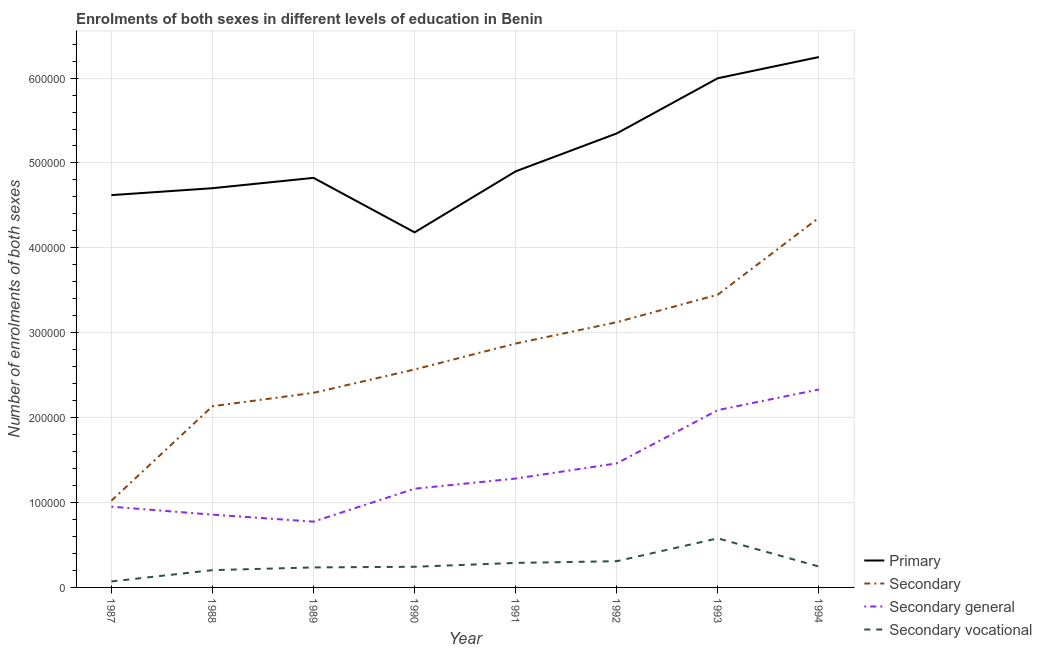How many different coloured lines are there?
Keep it short and to the point. 4. Does the line corresponding to number of enrolments in primary education intersect with the line corresponding to number of enrolments in secondary vocational education?
Your answer should be very brief. No. Is the number of lines equal to the number of legend labels?
Give a very brief answer. Yes. What is the number of enrolments in secondary vocational education in 1987?
Your answer should be very brief. 7050. Across all years, what is the maximum number of enrolments in secondary general education?
Provide a short and direct response. 2.33e+05. Across all years, what is the minimum number of enrolments in primary education?
Provide a succinct answer. 4.18e+05. In which year was the number of enrolments in primary education maximum?
Offer a terse response. 1994. What is the total number of enrolments in primary education in the graph?
Your answer should be compact. 4.08e+06. What is the difference between the number of enrolments in secondary vocational education in 1989 and that in 1990?
Offer a very short reply. -775. What is the difference between the number of enrolments in secondary general education in 1992 and the number of enrolments in primary education in 1991?
Give a very brief answer. -3.44e+05. What is the average number of enrolments in secondary general education per year?
Provide a short and direct response. 1.36e+05. In the year 1994, what is the difference between the number of enrolments in secondary vocational education and number of enrolments in primary education?
Your answer should be very brief. -6.00e+05. What is the ratio of the number of enrolments in secondary vocational education in 1988 to that in 1993?
Offer a very short reply. 0.35. Is the number of enrolments in secondary general education in 1990 less than that in 1991?
Offer a very short reply. Yes. Is the difference between the number of enrolments in secondary education in 1988 and 1992 greater than the difference between the number of enrolments in primary education in 1988 and 1992?
Your answer should be compact. No. What is the difference between the highest and the second highest number of enrolments in primary education?
Give a very brief answer. 2.49e+04. What is the difference between the highest and the lowest number of enrolments in secondary vocational education?
Your response must be concise. 5.08e+04. In how many years, is the number of enrolments in secondary vocational education greater than the average number of enrolments in secondary vocational education taken over all years?
Give a very brief answer. 3. Is it the case that in every year, the sum of the number of enrolments in primary education and number of enrolments in secondary vocational education is greater than the sum of number of enrolments in secondary education and number of enrolments in secondary general education?
Offer a very short reply. No. Does the number of enrolments in secondary education monotonically increase over the years?
Your answer should be very brief. Yes. How many lines are there?
Offer a very short reply. 4. What is the difference between two consecutive major ticks on the Y-axis?
Keep it short and to the point. 1.00e+05. Are the values on the major ticks of Y-axis written in scientific E-notation?
Provide a short and direct response. No. Does the graph contain grids?
Keep it short and to the point. Yes. How many legend labels are there?
Keep it short and to the point. 4. How are the legend labels stacked?
Your answer should be compact. Vertical. What is the title of the graph?
Your answer should be very brief. Enrolments of both sexes in different levels of education in Benin. Does "Efficiency of custom clearance process" appear as one of the legend labels in the graph?
Offer a very short reply. No. What is the label or title of the X-axis?
Provide a succinct answer. Year. What is the label or title of the Y-axis?
Ensure brevity in your answer.  Number of enrolments of both sexes. What is the Number of enrolments of both sexes of Primary in 1987?
Offer a terse response. 4.62e+05. What is the Number of enrolments of both sexes in Secondary in 1987?
Ensure brevity in your answer.  1.02e+05. What is the Number of enrolments of both sexes of Secondary general in 1987?
Offer a terse response. 9.51e+04. What is the Number of enrolments of both sexes of Secondary vocational in 1987?
Provide a short and direct response. 7050. What is the Number of enrolments of both sexes in Primary in 1988?
Your answer should be very brief. 4.70e+05. What is the Number of enrolments of both sexes of Secondary in 1988?
Offer a very short reply. 2.13e+05. What is the Number of enrolments of both sexes of Secondary general in 1988?
Make the answer very short. 8.58e+04. What is the Number of enrolments of both sexes in Secondary vocational in 1988?
Offer a terse response. 2.03e+04. What is the Number of enrolments of both sexes in Primary in 1989?
Provide a short and direct response. 4.82e+05. What is the Number of enrolments of both sexes in Secondary in 1989?
Provide a short and direct response. 2.29e+05. What is the Number of enrolments of both sexes in Secondary general in 1989?
Give a very brief answer. 7.75e+04. What is the Number of enrolments of both sexes of Secondary vocational in 1989?
Give a very brief answer. 2.36e+04. What is the Number of enrolments of both sexes in Primary in 1990?
Ensure brevity in your answer.  4.18e+05. What is the Number of enrolments of both sexes of Secondary in 1990?
Your response must be concise. 2.57e+05. What is the Number of enrolments of both sexes of Secondary general in 1990?
Ensure brevity in your answer.  1.16e+05. What is the Number of enrolments of both sexes in Secondary vocational in 1990?
Give a very brief answer. 2.43e+04. What is the Number of enrolments of both sexes in Primary in 1991?
Make the answer very short. 4.90e+05. What is the Number of enrolments of both sexes of Secondary in 1991?
Provide a short and direct response. 2.87e+05. What is the Number of enrolments of both sexes of Secondary general in 1991?
Your answer should be very brief. 1.28e+05. What is the Number of enrolments of both sexes of Secondary vocational in 1991?
Keep it short and to the point. 2.89e+04. What is the Number of enrolments of both sexes in Primary in 1992?
Your answer should be very brief. 5.35e+05. What is the Number of enrolments of both sexes of Secondary in 1992?
Ensure brevity in your answer.  3.12e+05. What is the Number of enrolments of both sexes of Secondary general in 1992?
Provide a succinct answer. 1.46e+05. What is the Number of enrolments of both sexes of Secondary vocational in 1992?
Offer a terse response. 3.09e+04. What is the Number of enrolments of both sexes of Primary in 1993?
Keep it short and to the point. 6.00e+05. What is the Number of enrolments of both sexes in Secondary in 1993?
Your answer should be compact. 3.45e+05. What is the Number of enrolments of both sexes of Secondary general in 1993?
Offer a very short reply. 2.09e+05. What is the Number of enrolments of both sexes in Secondary vocational in 1993?
Your answer should be very brief. 5.78e+04. What is the Number of enrolments of both sexes in Primary in 1994?
Offer a terse response. 6.25e+05. What is the Number of enrolments of both sexes of Secondary in 1994?
Make the answer very short. 4.35e+05. What is the Number of enrolments of both sexes of Secondary general in 1994?
Give a very brief answer. 2.33e+05. What is the Number of enrolments of both sexes in Secondary vocational in 1994?
Keep it short and to the point. 2.46e+04. Across all years, what is the maximum Number of enrolments of both sexes in Primary?
Ensure brevity in your answer.  6.25e+05. Across all years, what is the maximum Number of enrolments of both sexes of Secondary?
Offer a very short reply. 4.35e+05. Across all years, what is the maximum Number of enrolments of both sexes in Secondary general?
Your answer should be very brief. 2.33e+05. Across all years, what is the maximum Number of enrolments of both sexes in Secondary vocational?
Give a very brief answer. 5.78e+04. Across all years, what is the minimum Number of enrolments of both sexes of Primary?
Keep it short and to the point. 4.18e+05. Across all years, what is the minimum Number of enrolments of both sexes of Secondary?
Your response must be concise. 1.02e+05. Across all years, what is the minimum Number of enrolments of both sexes in Secondary general?
Your response must be concise. 7.75e+04. Across all years, what is the minimum Number of enrolments of both sexes of Secondary vocational?
Your answer should be compact. 7050. What is the total Number of enrolments of both sexes of Primary in the graph?
Ensure brevity in your answer.  4.08e+06. What is the total Number of enrolments of both sexes of Secondary in the graph?
Keep it short and to the point. 2.18e+06. What is the total Number of enrolments of both sexes of Secondary general in the graph?
Offer a very short reply. 1.09e+06. What is the total Number of enrolments of both sexes of Secondary vocational in the graph?
Give a very brief answer. 2.18e+05. What is the difference between the Number of enrolments of both sexes in Primary in 1987 and that in 1988?
Your answer should be compact. -8157. What is the difference between the Number of enrolments of both sexes of Secondary in 1987 and that in 1988?
Your response must be concise. -1.11e+05. What is the difference between the Number of enrolments of both sexes in Secondary general in 1987 and that in 1988?
Ensure brevity in your answer.  9368. What is the difference between the Number of enrolments of both sexes in Secondary vocational in 1987 and that in 1988?
Give a very brief answer. -1.33e+04. What is the difference between the Number of enrolments of both sexes of Primary in 1987 and that in 1989?
Make the answer very short. -2.03e+04. What is the difference between the Number of enrolments of both sexes of Secondary in 1987 and that in 1989?
Offer a very short reply. -1.27e+05. What is the difference between the Number of enrolments of both sexes of Secondary general in 1987 and that in 1989?
Make the answer very short. 1.76e+04. What is the difference between the Number of enrolments of both sexes in Secondary vocational in 1987 and that in 1989?
Offer a very short reply. -1.65e+04. What is the difference between the Number of enrolments of both sexes of Primary in 1987 and that in 1990?
Your response must be concise. 4.38e+04. What is the difference between the Number of enrolments of both sexes in Secondary in 1987 and that in 1990?
Provide a short and direct response. -1.55e+05. What is the difference between the Number of enrolments of both sexes of Secondary general in 1987 and that in 1990?
Your answer should be compact. -2.12e+04. What is the difference between the Number of enrolments of both sexes in Secondary vocational in 1987 and that in 1990?
Make the answer very short. -1.73e+04. What is the difference between the Number of enrolments of both sexes in Primary in 1987 and that in 1991?
Your answer should be compact. -2.80e+04. What is the difference between the Number of enrolments of both sexes in Secondary in 1987 and that in 1991?
Make the answer very short. -1.85e+05. What is the difference between the Number of enrolments of both sexes in Secondary general in 1987 and that in 1991?
Give a very brief answer. -3.31e+04. What is the difference between the Number of enrolments of both sexes in Secondary vocational in 1987 and that in 1991?
Your response must be concise. -2.18e+04. What is the difference between the Number of enrolments of both sexes in Primary in 1987 and that in 1992?
Offer a terse response. -7.27e+04. What is the difference between the Number of enrolments of both sexes in Secondary in 1987 and that in 1992?
Keep it short and to the point. -2.10e+05. What is the difference between the Number of enrolments of both sexes of Secondary general in 1987 and that in 1992?
Offer a terse response. -5.10e+04. What is the difference between the Number of enrolments of both sexes of Secondary vocational in 1987 and that in 1992?
Provide a succinct answer. -2.39e+04. What is the difference between the Number of enrolments of both sexes in Primary in 1987 and that in 1993?
Give a very brief answer. -1.38e+05. What is the difference between the Number of enrolments of both sexes of Secondary in 1987 and that in 1993?
Provide a succinct answer. -2.43e+05. What is the difference between the Number of enrolments of both sexes of Secondary general in 1987 and that in 1993?
Make the answer very short. -1.14e+05. What is the difference between the Number of enrolments of both sexes in Secondary vocational in 1987 and that in 1993?
Your response must be concise. -5.08e+04. What is the difference between the Number of enrolments of both sexes of Primary in 1987 and that in 1994?
Make the answer very short. -1.63e+05. What is the difference between the Number of enrolments of both sexes in Secondary in 1987 and that in 1994?
Your answer should be compact. -3.33e+05. What is the difference between the Number of enrolments of both sexes in Secondary general in 1987 and that in 1994?
Your response must be concise. -1.38e+05. What is the difference between the Number of enrolments of both sexes of Secondary vocational in 1987 and that in 1994?
Your answer should be compact. -1.76e+04. What is the difference between the Number of enrolments of both sexes of Primary in 1988 and that in 1989?
Your response must be concise. -1.22e+04. What is the difference between the Number of enrolments of both sexes of Secondary in 1988 and that in 1989?
Your response must be concise. -1.58e+04. What is the difference between the Number of enrolments of both sexes in Secondary general in 1988 and that in 1989?
Ensure brevity in your answer.  8253. What is the difference between the Number of enrolments of both sexes of Secondary vocational in 1988 and that in 1989?
Offer a terse response. -3224. What is the difference between the Number of enrolments of both sexes in Primary in 1988 and that in 1990?
Your answer should be very brief. 5.20e+04. What is the difference between the Number of enrolments of both sexes in Secondary in 1988 and that in 1990?
Ensure brevity in your answer.  -4.33e+04. What is the difference between the Number of enrolments of both sexes of Secondary general in 1988 and that in 1990?
Your answer should be compact. -3.05e+04. What is the difference between the Number of enrolments of both sexes of Secondary vocational in 1988 and that in 1990?
Provide a succinct answer. -3999. What is the difference between the Number of enrolments of both sexes of Primary in 1988 and that in 1991?
Give a very brief answer. -1.99e+04. What is the difference between the Number of enrolments of both sexes in Secondary in 1988 and that in 1991?
Ensure brevity in your answer.  -7.38e+04. What is the difference between the Number of enrolments of both sexes of Secondary general in 1988 and that in 1991?
Make the answer very short. -4.25e+04. What is the difference between the Number of enrolments of both sexes of Secondary vocational in 1988 and that in 1991?
Ensure brevity in your answer.  -8524. What is the difference between the Number of enrolments of both sexes of Primary in 1988 and that in 1992?
Offer a terse response. -6.45e+04. What is the difference between the Number of enrolments of both sexes in Secondary in 1988 and that in 1992?
Provide a succinct answer. -9.90e+04. What is the difference between the Number of enrolments of both sexes of Secondary general in 1988 and that in 1992?
Provide a succinct answer. -6.04e+04. What is the difference between the Number of enrolments of both sexes of Secondary vocational in 1988 and that in 1992?
Provide a succinct answer. -1.06e+04. What is the difference between the Number of enrolments of both sexes of Primary in 1988 and that in 1993?
Make the answer very short. -1.30e+05. What is the difference between the Number of enrolments of both sexes of Secondary in 1988 and that in 1993?
Your answer should be very brief. -1.31e+05. What is the difference between the Number of enrolments of both sexes of Secondary general in 1988 and that in 1993?
Keep it short and to the point. -1.23e+05. What is the difference between the Number of enrolments of both sexes of Secondary vocational in 1988 and that in 1993?
Keep it short and to the point. -3.75e+04. What is the difference between the Number of enrolments of both sexes in Primary in 1988 and that in 1994?
Make the answer very short. -1.55e+05. What is the difference between the Number of enrolments of both sexes of Secondary in 1988 and that in 1994?
Provide a short and direct response. -2.22e+05. What is the difference between the Number of enrolments of both sexes in Secondary general in 1988 and that in 1994?
Your answer should be compact. -1.47e+05. What is the difference between the Number of enrolments of both sexes of Secondary vocational in 1988 and that in 1994?
Your answer should be compact. -4283. What is the difference between the Number of enrolments of both sexes of Primary in 1989 and that in 1990?
Your response must be concise. 6.42e+04. What is the difference between the Number of enrolments of both sexes in Secondary in 1989 and that in 1990?
Make the answer very short. -2.75e+04. What is the difference between the Number of enrolments of both sexes of Secondary general in 1989 and that in 1990?
Give a very brief answer. -3.88e+04. What is the difference between the Number of enrolments of both sexes in Secondary vocational in 1989 and that in 1990?
Your answer should be very brief. -775. What is the difference between the Number of enrolments of both sexes in Primary in 1989 and that in 1991?
Make the answer very short. -7678. What is the difference between the Number of enrolments of both sexes in Secondary in 1989 and that in 1991?
Provide a short and direct response. -5.81e+04. What is the difference between the Number of enrolments of both sexes in Secondary general in 1989 and that in 1991?
Ensure brevity in your answer.  -5.08e+04. What is the difference between the Number of enrolments of both sexes of Secondary vocational in 1989 and that in 1991?
Provide a succinct answer. -5300. What is the difference between the Number of enrolments of both sexes in Primary in 1989 and that in 1992?
Make the answer very short. -5.24e+04. What is the difference between the Number of enrolments of both sexes of Secondary in 1989 and that in 1992?
Provide a succinct answer. -8.32e+04. What is the difference between the Number of enrolments of both sexes of Secondary general in 1989 and that in 1992?
Offer a very short reply. -6.86e+04. What is the difference between the Number of enrolments of both sexes in Secondary vocational in 1989 and that in 1992?
Offer a very short reply. -7337. What is the difference between the Number of enrolments of both sexes in Primary in 1989 and that in 1993?
Ensure brevity in your answer.  -1.17e+05. What is the difference between the Number of enrolments of both sexes in Secondary in 1989 and that in 1993?
Make the answer very short. -1.16e+05. What is the difference between the Number of enrolments of both sexes of Secondary general in 1989 and that in 1993?
Your answer should be very brief. -1.31e+05. What is the difference between the Number of enrolments of both sexes of Secondary vocational in 1989 and that in 1993?
Provide a succinct answer. -3.43e+04. What is the difference between the Number of enrolments of both sexes of Primary in 1989 and that in 1994?
Ensure brevity in your answer.  -1.42e+05. What is the difference between the Number of enrolments of both sexes of Secondary in 1989 and that in 1994?
Provide a short and direct response. -2.06e+05. What is the difference between the Number of enrolments of both sexes in Secondary general in 1989 and that in 1994?
Make the answer very short. -1.56e+05. What is the difference between the Number of enrolments of both sexes of Secondary vocational in 1989 and that in 1994?
Your response must be concise. -1059. What is the difference between the Number of enrolments of both sexes of Primary in 1990 and that in 1991?
Offer a terse response. -7.19e+04. What is the difference between the Number of enrolments of both sexes of Secondary in 1990 and that in 1991?
Provide a short and direct response. -3.05e+04. What is the difference between the Number of enrolments of both sexes in Secondary general in 1990 and that in 1991?
Offer a terse response. -1.20e+04. What is the difference between the Number of enrolments of both sexes in Secondary vocational in 1990 and that in 1991?
Your answer should be compact. -4525. What is the difference between the Number of enrolments of both sexes in Primary in 1990 and that in 1992?
Give a very brief answer. -1.17e+05. What is the difference between the Number of enrolments of both sexes of Secondary in 1990 and that in 1992?
Your answer should be very brief. -5.57e+04. What is the difference between the Number of enrolments of both sexes in Secondary general in 1990 and that in 1992?
Make the answer very short. -2.98e+04. What is the difference between the Number of enrolments of both sexes in Secondary vocational in 1990 and that in 1992?
Provide a succinct answer. -6562. What is the difference between the Number of enrolments of both sexes in Primary in 1990 and that in 1993?
Ensure brevity in your answer.  -1.82e+05. What is the difference between the Number of enrolments of both sexes of Secondary in 1990 and that in 1993?
Offer a very short reply. -8.81e+04. What is the difference between the Number of enrolments of both sexes of Secondary general in 1990 and that in 1993?
Offer a very short reply. -9.26e+04. What is the difference between the Number of enrolments of both sexes in Secondary vocational in 1990 and that in 1993?
Your answer should be very brief. -3.35e+04. What is the difference between the Number of enrolments of both sexes in Primary in 1990 and that in 1994?
Keep it short and to the point. -2.07e+05. What is the difference between the Number of enrolments of both sexes in Secondary in 1990 and that in 1994?
Ensure brevity in your answer.  -1.79e+05. What is the difference between the Number of enrolments of both sexes in Secondary general in 1990 and that in 1994?
Your answer should be compact. -1.17e+05. What is the difference between the Number of enrolments of both sexes in Secondary vocational in 1990 and that in 1994?
Provide a short and direct response. -284. What is the difference between the Number of enrolments of both sexes in Primary in 1991 and that in 1992?
Provide a short and direct response. -4.47e+04. What is the difference between the Number of enrolments of both sexes of Secondary in 1991 and that in 1992?
Offer a terse response. -2.51e+04. What is the difference between the Number of enrolments of both sexes in Secondary general in 1991 and that in 1992?
Your answer should be compact. -1.79e+04. What is the difference between the Number of enrolments of both sexes of Secondary vocational in 1991 and that in 1992?
Your answer should be very brief. -2037. What is the difference between the Number of enrolments of both sexes in Primary in 1991 and that in 1993?
Keep it short and to the point. -1.10e+05. What is the difference between the Number of enrolments of both sexes of Secondary in 1991 and that in 1993?
Provide a short and direct response. -5.76e+04. What is the difference between the Number of enrolments of both sexes of Secondary general in 1991 and that in 1993?
Offer a very short reply. -8.06e+04. What is the difference between the Number of enrolments of both sexes in Secondary vocational in 1991 and that in 1993?
Provide a short and direct response. -2.90e+04. What is the difference between the Number of enrolments of both sexes of Primary in 1991 and that in 1994?
Offer a very short reply. -1.35e+05. What is the difference between the Number of enrolments of both sexes of Secondary in 1991 and that in 1994?
Your answer should be compact. -1.48e+05. What is the difference between the Number of enrolments of both sexes of Secondary general in 1991 and that in 1994?
Keep it short and to the point. -1.05e+05. What is the difference between the Number of enrolments of both sexes of Secondary vocational in 1991 and that in 1994?
Keep it short and to the point. 4241. What is the difference between the Number of enrolments of both sexes in Primary in 1992 and that in 1993?
Keep it short and to the point. -6.50e+04. What is the difference between the Number of enrolments of both sexes of Secondary in 1992 and that in 1993?
Provide a succinct answer. -3.25e+04. What is the difference between the Number of enrolments of both sexes in Secondary general in 1992 and that in 1993?
Ensure brevity in your answer.  -6.28e+04. What is the difference between the Number of enrolments of both sexes of Secondary vocational in 1992 and that in 1993?
Ensure brevity in your answer.  -2.69e+04. What is the difference between the Number of enrolments of both sexes in Primary in 1992 and that in 1994?
Your response must be concise. -9.00e+04. What is the difference between the Number of enrolments of both sexes in Secondary in 1992 and that in 1994?
Provide a succinct answer. -1.23e+05. What is the difference between the Number of enrolments of both sexes in Secondary general in 1992 and that in 1994?
Your response must be concise. -8.70e+04. What is the difference between the Number of enrolments of both sexes of Secondary vocational in 1992 and that in 1994?
Provide a succinct answer. 6278. What is the difference between the Number of enrolments of both sexes in Primary in 1993 and that in 1994?
Ensure brevity in your answer.  -2.49e+04. What is the difference between the Number of enrolments of both sexes of Secondary in 1993 and that in 1994?
Make the answer very short. -9.06e+04. What is the difference between the Number of enrolments of both sexes of Secondary general in 1993 and that in 1994?
Offer a terse response. -2.43e+04. What is the difference between the Number of enrolments of both sexes in Secondary vocational in 1993 and that in 1994?
Ensure brevity in your answer.  3.32e+04. What is the difference between the Number of enrolments of both sexes in Primary in 1987 and the Number of enrolments of both sexes in Secondary in 1988?
Provide a short and direct response. 2.49e+05. What is the difference between the Number of enrolments of both sexes of Primary in 1987 and the Number of enrolments of both sexes of Secondary general in 1988?
Offer a terse response. 3.76e+05. What is the difference between the Number of enrolments of both sexes of Primary in 1987 and the Number of enrolments of both sexes of Secondary vocational in 1988?
Offer a terse response. 4.42e+05. What is the difference between the Number of enrolments of both sexes of Secondary in 1987 and the Number of enrolments of both sexes of Secondary general in 1988?
Offer a terse response. 1.64e+04. What is the difference between the Number of enrolments of both sexes in Secondary in 1987 and the Number of enrolments of both sexes in Secondary vocational in 1988?
Provide a succinct answer. 8.18e+04. What is the difference between the Number of enrolments of both sexes in Secondary general in 1987 and the Number of enrolments of both sexes in Secondary vocational in 1988?
Ensure brevity in your answer.  7.48e+04. What is the difference between the Number of enrolments of both sexes in Primary in 1987 and the Number of enrolments of both sexes in Secondary in 1989?
Give a very brief answer. 2.33e+05. What is the difference between the Number of enrolments of both sexes in Primary in 1987 and the Number of enrolments of both sexes in Secondary general in 1989?
Provide a succinct answer. 3.85e+05. What is the difference between the Number of enrolments of both sexes of Primary in 1987 and the Number of enrolments of both sexes of Secondary vocational in 1989?
Give a very brief answer. 4.39e+05. What is the difference between the Number of enrolments of both sexes of Secondary in 1987 and the Number of enrolments of both sexes of Secondary general in 1989?
Offer a terse response. 2.47e+04. What is the difference between the Number of enrolments of both sexes in Secondary in 1987 and the Number of enrolments of both sexes in Secondary vocational in 1989?
Keep it short and to the point. 7.86e+04. What is the difference between the Number of enrolments of both sexes of Secondary general in 1987 and the Number of enrolments of both sexes of Secondary vocational in 1989?
Provide a succinct answer. 7.16e+04. What is the difference between the Number of enrolments of both sexes of Primary in 1987 and the Number of enrolments of both sexes of Secondary in 1990?
Offer a terse response. 2.05e+05. What is the difference between the Number of enrolments of both sexes of Primary in 1987 and the Number of enrolments of both sexes of Secondary general in 1990?
Make the answer very short. 3.46e+05. What is the difference between the Number of enrolments of both sexes of Primary in 1987 and the Number of enrolments of both sexes of Secondary vocational in 1990?
Give a very brief answer. 4.38e+05. What is the difference between the Number of enrolments of both sexes of Secondary in 1987 and the Number of enrolments of both sexes of Secondary general in 1990?
Offer a terse response. -1.41e+04. What is the difference between the Number of enrolments of both sexes of Secondary in 1987 and the Number of enrolments of both sexes of Secondary vocational in 1990?
Ensure brevity in your answer.  7.78e+04. What is the difference between the Number of enrolments of both sexes in Secondary general in 1987 and the Number of enrolments of both sexes in Secondary vocational in 1990?
Ensure brevity in your answer.  7.08e+04. What is the difference between the Number of enrolments of both sexes in Primary in 1987 and the Number of enrolments of both sexes in Secondary in 1991?
Offer a terse response. 1.75e+05. What is the difference between the Number of enrolments of both sexes of Primary in 1987 and the Number of enrolments of both sexes of Secondary general in 1991?
Give a very brief answer. 3.34e+05. What is the difference between the Number of enrolments of both sexes of Primary in 1987 and the Number of enrolments of both sexes of Secondary vocational in 1991?
Keep it short and to the point. 4.33e+05. What is the difference between the Number of enrolments of both sexes in Secondary in 1987 and the Number of enrolments of both sexes in Secondary general in 1991?
Give a very brief answer. -2.61e+04. What is the difference between the Number of enrolments of both sexes of Secondary in 1987 and the Number of enrolments of both sexes of Secondary vocational in 1991?
Your answer should be very brief. 7.33e+04. What is the difference between the Number of enrolments of both sexes in Secondary general in 1987 and the Number of enrolments of both sexes in Secondary vocational in 1991?
Provide a short and direct response. 6.63e+04. What is the difference between the Number of enrolments of both sexes of Primary in 1987 and the Number of enrolments of both sexes of Secondary in 1992?
Your answer should be very brief. 1.50e+05. What is the difference between the Number of enrolments of both sexes in Primary in 1987 and the Number of enrolments of both sexes in Secondary general in 1992?
Provide a succinct answer. 3.16e+05. What is the difference between the Number of enrolments of both sexes in Primary in 1987 and the Number of enrolments of both sexes in Secondary vocational in 1992?
Your response must be concise. 4.31e+05. What is the difference between the Number of enrolments of both sexes of Secondary in 1987 and the Number of enrolments of both sexes of Secondary general in 1992?
Offer a very short reply. -4.40e+04. What is the difference between the Number of enrolments of both sexes of Secondary in 1987 and the Number of enrolments of both sexes of Secondary vocational in 1992?
Your response must be concise. 7.13e+04. What is the difference between the Number of enrolments of both sexes in Secondary general in 1987 and the Number of enrolments of both sexes in Secondary vocational in 1992?
Your answer should be very brief. 6.42e+04. What is the difference between the Number of enrolments of both sexes of Primary in 1987 and the Number of enrolments of both sexes of Secondary in 1993?
Provide a short and direct response. 1.17e+05. What is the difference between the Number of enrolments of both sexes in Primary in 1987 and the Number of enrolments of both sexes in Secondary general in 1993?
Offer a very short reply. 2.53e+05. What is the difference between the Number of enrolments of both sexes in Primary in 1987 and the Number of enrolments of both sexes in Secondary vocational in 1993?
Offer a very short reply. 4.04e+05. What is the difference between the Number of enrolments of both sexes of Secondary in 1987 and the Number of enrolments of both sexes of Secondary general in 1993?
Your answer should be very brief. -1.07e+05. What is the difference between the Number of enrolments of both sexes in Secondary in 1987 and the Number of enrolments of both sexes in Secondary vocational in 1993?
Your response must be concise. 4.43e+04. What is the difference between the Number of enrolments of both sexes in Secondary general in 1987 and the Number of enrolments of both sexes in Secondary vocational in 1993?
Provide a succinct answer. 3.73e+04. What is the difference between the Number of enrolments of both sexes of Primary in 1987 and the Number of enrolments of both sexes of Secondary in 1994?
Offer a terse response. 2.67e+04. What is the difference between the Number of enrolments of both sexes in Primary in 1987 and the Number of enrolments of both sexes in Secondary general in 1994?
Keep it short and to the point. 2.29e+05. What is the difference between the Number of enrolments of both sexes in Primary in 1987 and the Number of enrolments of both sexes in Secondary vocational in 1994?
Offer a terse response. 4.37e+05. What is the difference between the Number of enrolments of both sexes of Secondary in 1987 and the Number of enrolments of both sexes of Secondary general in 1994?
Provide a short and direct response. -1.31e+05. What is the difference between the Number of enrolments of both sexes in Secondary in 1987 and the Number of enrolments of both sexes in Secondary vocational in 1994?
Provide a short and direct response. 7.75e+04. What is the difference between the Number of enrolments of both sexes in Secondary general in 1987 and the Number of enrolments of both sexes in Secondary vocational in 1994?
Make the answer very short. 7.05e+04. What is the difference between the Number of enrolments of both sexes in Primary in 1988 and the Number of enrolments of both sexes in Secondary in 1989?
Provide a succinct answer. 2.41e+05. What is the difference between the Number of enrolments of both sexes of Primary in 1988 and the Number of enrolments of both sexes of Secondary general in 1989?
Ensure brevity in your answer.  3.93e+05. What is the difference between the Number of enrolments of both sexes of Primary in 1988 and the Number of enrolments of both sexes of Secondary vocational in 1989?
Offer a very short reply. 4.47e+05. What is the difference between the Number of enrolments of both sexes in Secondary in 1988 and the Number of enrolments of both sexes in Secondary general in 1989?
Make the answer very short. 1.36e+05. What is the difference between the Number of enrolments of both sexes in Secondary in 1988 and the Number of enrolments of both sexes in Secondary vocational in 1989?
Offer a very short reply. 1.90e+05. What is the difference between the Number of enrolments of both sexes of Secondary general in 1988 and the Number of enrolments of both sexes of Secondary vocational in 1989?
Ensure brevity in your answer.  6.22e+04. What is the difference between the Number of enrolments of both sexes of Primary in 1988 and the Number of enrolments of both sexes of Secondary in 1990?
Offer a very short reply. 2.14e+05. What is the difference between the Number of enrolments of both sexes in Primary in 1988 and the Number of enrolments of both sexes in Secondary general in 1990?
Give a very brief answer. 3.54e+05. What is the difference between the Number of enrolments of both sexes of Primary in 1988 and the Number of enrolments of both sexes of Secondary vocational in 1990?
Ensure brevity in your answer.  4.46e+05. What is the difference between the Number of enrolments of both sexes in Secondary in 1988 and the Number of enrolments of both sexes in Secondary general in 1990?
Make the answer very short. 9.72e+04. What is the difference between the Number of enrolments of both sexes in Secondary in 1988 and the Number of enrolments of both sexes in Secondary vocational in 1990?
Your answer should be very brief. 1.89e+05. What is the difference between the Number of enrolments of both sexes of Secondary general in 1988 and the Number of enrolments of both sexes of Secondary vocational in 1990?
Your response must be concise. 6.14e+04. What is the difference between the Number of enrolments of both sexes of Primary in 1988 and the Number of enrolments of both sexes of Secondary in 1991?
Provide a succinct answer. 1.83e+05. What is the difference between the Number of enrolments of both sexes in Primary in 1988 and the Number of enrolments of both sexes in Secondary general in 1991?
Provide a short and direct response. 3.42e+05. What is the difference between the Number of enrolments of both sexes in Primary in 1988 and the Number of enrolments of both sexes in Secondary vocational in 1991?
Your answer should be very brief. 4.41e+05. What is the difference between the Number of enrolments of both sexes in Secondary in 1988 and the Number of enrolments of both sexes in Secondary general in 1991?
Offer a terse response. 8.52e+04. What is the difference between the Number of enrolments of both sexes of Secondary in 1988 and the Number of enrolments of both sexes of Secondary vocational in 1991?
Make the answer very short. 1.85e+05. What is the difference between the Number of enrolments of both sexes in Secondary general in 1988 and the Number of enrolments of both sexes in Secondary vocational in 1991?
Give a very brief answer. 5.69e+04. What is the difference between the Number of enrolments of both sexes in Primary in 1988 and the Number of enrolments of both sexes in Secondary in 1992?
Offer a very short reply. 1.58e+05. What is the difference between the Number of enrolments of both sexes of Primary in 1988 and the Number of enrolments of both sexes of Secondary general in 1992?
Your answer should be compact. 3.24e+05. What is the difference between the Number of enrolments of both sexes in Primary in 1988 and the Number of enrolments of both sexes in Secondary vocational in 1992?
Offer a terse response. 4.39e+05. What is the difference between the Number of enrolments of both sexes in Secondary in 1988 and the Number of enrolments of both sexes in Secondary general in 1992?
Make the answer very short. 6.73e+04. What is the difference between the Number of enrolments of both sexes of Secondary in 1988 and the Number of enrolments of both sexes of Secondary vocational in 1992?
Offer a very short reply. 1.83e+05. What is the difference between the Number of enrolments of both sexes of Secondary general in 1988 and the Number of enrolments of both sexes of Secondary vocational in 1992?
Make the answer very short. 5.48e+04. What is the difference between the Number of enrolments of both sexes in Primary in 1988 and the Number of enrolments of both sexes in Secondary in 1993?
Provide a short and direct response. 1.25e+05. What is the difference between the Number of enrolments of both sexes of Primary in 1988 and the Number of enrolments of both sexes of Secondary general in 1993?
Offer a terse response. 2.61e+05. What is the difference between the Number of enrolments of both sexes of Primary in 1988 and the Number of enrolments of both sexes of Secondary vocational in 1993?
Offer a terse response. 4.12e+05. What is the difference between the Number of enrolments of both sexes of Secondary in 1988 and the Number of enrolments of both sexes of Secondary general in 1993?
Make the answer very short. 4589. What is the difference between the Number of enrolments of both sexes of Secondary in 1988 and the Number of enrolments of both sexes of Secondary vocational in 1993?
Make the answer very short. 1.56e+05. What is the difference between the Number of enrolments of both sexes in Secondary general in 1988 and the Number of enrolments of both sexes in Secondary vocational in 1993?
Keep it short and to the point. 2.79e+04. What is the difference between the Number of enrolments of both sexes in Primary in 1988 and the Number of enrolments of both sexes in Secondary in 1994?
Your response must be concise. 3.48e+04. What is the difference between the Number of enrolments of both sexes in Primary in 1988 and the Number of enrolments of both sexes in Secondary general in 1994?
Make the answer very short. 2.37e+05. What is the difference between the Number of enrolments of both sexes of Primary in 1988 and the Number of enrolments of both sexes of Secondary vocational in 1994?
Your answer should be compact. 4.46e+05. What is the difference between the Number of enrolments of both sexes of Secondary in 1988 and the Number of enrolments of both sexes of Secondary general in 1994?
Your answer should be very brief. -1.97e+04. What is the difference between the Number of enrolments of both sexes of Secondary in 1988 and the Number of enrolments of both sexes of Secondary vocational in 1994?
Keep it short and to the point. 1.89e+05. What is the difference between the Number of enrolments of both sexes in Secondary general in 1988 and the Number of enrolments of both sexes in Secondary vocational in 1994?
Make the answer very short. 6.11e+04. What is the difference between the Number of enrolments of both sexes of Primary in 1989 and the Number of enrolments of both sexes of Secondary in 1990?
Offer a very short reply. 2.26e+05. What is the difference between the Number of enrolments of both sexes in Primary in 1989 and the Number of enrolments of both sexes in Secondary general in 1990?
Make the answer very short. 3.66e+05. What is the difference between the Number of enrolments of both sexes in Primary in 1989 and the Number of enrolments of both sexes in Secondary vocational in 1990?
Keep it short and to the point. 4.58e+05. What is the difference between the Number of enrolments of both sexes in Secondary in 1989 and the Number of enrolments of both sexes in Secondary general in 1990?
Make the answer very short. 1.13e+05. What is the difference between the Number of enrolments of both sexes of Secondary in 1989 and the Number of enrolments of both sexes of Secondary vocational in 1990?
Your answer should be compact. 2.05e+05. What is the difference between the Number of enrolments of both sexes of Secondary general in 1989 and the Number of enrolments of both sexes of Secondary vocational in 1990?
Your response must be concise. 5.32e+04. What is the difference between the Number of enrolments of both sexes of Primary in 1989 and the Number of enrolments of both sexes of Secondary in 1991?
Your answer should be compact. 1.95e+05. What is the difference between the Number of enrolments of both sexes in Primary in 1989 and the Number of enrolments of both sexes in Secondary general in 1991?
Give a very brief answer. 3.54e+05. What is the difference between the Number of enrolments of both sexes of Primary in 1989 and the Number of enrolments of both sexes of Secondary vocational in 1991?
Keep it short and to the point. 4.54e+05. What is the difference between the Number of enrolments of both sexes of Secondary in 1989 and the Number of enrolments of both sexes of Secondary general in 1991?
Give a very brief answer. 1.01e+05. What is the difference between the Number of enrolments of both sexes of Secondary in 1989 and the Number of enrolments of both sexes of Secondary vocational in 1991?
Give a very brief answer. 2.00e+05. What is the difference between the Number of enrolments of both sexes in Secondary general in 1989 and the Number of enrolments of both sexes in Secondary vocational in 1991?
Your response must be concise. 4.86e+04. What is the difference between the Number of enrolments of both sexes of Primary in 1989 and the Number of enrolments of both sexes of Secondary in 1992?
Offer a terse response. 1.70e+05. What is the difference between the Number of enrolments of both sexes of Primary in 1989 and the Number of enrolments of both sexes of Secondary general in 1992?
Your answer should be very brief. 3.36e+05. What is the difference between the Number of enrolments of both sexes of Primary in 1989 and the Number of enrolments of both sexes of Secondary vocational in 1992?
Give a very brief answer. 4.52e+05. What is the difference between the Number of enrolments of both sexes in Secondary in 1989 and the Number of enrolments of both sexes in Secondary general in 1992?
Offer a terse response. 8.31e+04. What is the difference between the Number of enrolments of both sexes of Secondary in 1989 and the Number of enrolments of both sexes of Secondary vocational in 1992?
Your answer should be compact. 1.98e+05. What is the difference between the Number of enrolments of both sexes in Secondary general in 1989 and the Number of enrolments of both sexes in Secondary vocational in 1992?
Your response must be concise. 4.66e+04. What is the difference between the Number of enrolments of both sexes in Primary in 1989 and the Number of enrolments of both sexes in Secondary in 1993?
Provide a short and direct response. 1.38e+05. What is the difference between the Number of enrolments of both sexes of Primary in 1989 and the Number of enrolments of both sexes of Secondary general in 1993?
Make the answer very short. 2.74e+05. What is the difference between the Number of enrolments of both sexes in Primary in 1989 and the Number of enrolments of both sexes in Secondary vocational in 1993?
Keep it short and to the point. 4.25e+05. What is the difference between the Number of enrolments of both sexes of Secondary in 1989 and the Number of enrolments of both sexes of Secondary general in 1993?
Your answer should be compact. 2.03e+04. What is the difference between the Number of enrolments of both sexes in Secondary in 1989 and the Number of enrolments of both sexes in Secondary vocational in 1993?
Provide a short and direct response. 1.71e+05. What is the difference between the Number of enrolments of both sexes in Secondary general in 1989 and the Number of enrolments of both sexes in Secondary vocational in 1993?
Your answer should be very brief. 1.97e+04. What is the difference between the Number of enrolments of both sexes of Primary in 1989 and the Number of enrolments of both sexes of Secondary in 1994?
Provide a short and direct response. 4.70e+04. What is the difference between the Number of enrolments of both sexes of Primary in 1989 and the Number of enrolments of both sexes of Secondary general in 1994?
Your answer should be compact. 2.49e+05. What is the difference between the Number of enrolments of both sexes in Primary in 1989 and the Number of enrolments of both sexes in Secondary vocational in 1994?
Make the answer very short. 4.58e+05. What is the difference between the Number of enrolments of both sexes in Secondary in 1989 and the Number of enrolments of both sexes in Secondary general in 1994?
Make the answer very short. -3949. What is the difference between the Number of enrolments of both sexes in Secondary in 1989 and the Number of enrolments of both sexes in Secondary vocational in 1994?
Give a very brief answer. 2.05e+05. What is the difference between the Number of enrolments of both sexes in Secondary general in 1989 and the Number of enrolments of both sexes in Secondary vocational in 1994?
Offer a very short reply. 5.29e+04. What is the difference between the Number of enrolments of both sexes of Primary in 1990 and the Number of enrolments of both sexes of Secondary in 1991?
Give a very brief answer. 1.31e+05. What is the difference between the Number of enrolments of both sexes in Primary in 1990 and the Number of enrolments of both sexes in Secondary general in 1991?
Your answer should be very brief. 2.90e+05. What is the difference between the Number of enrolments of both sexes of Primary in 1990 and the Number of enrolments of both sexes of Secondary vocational in 1991?
Your answer should be very brief. 3.89e+05. What is the difference between the Number of enrolments of both sexes of Secondary in 1990 and the Number of enrolments of both sexes of Secondary general in 1991?
Your response must be concise. 1.28e+05. What is the difference between the Number of enrolments of both sexes of Secondary in 1990 and the Number of enrolments of both sexes of Secondary vocational in 1991?
Ensure brevity in your answer.  2.28e+05. What is the difference between the Number of enrolments of both sexes in Secondary general in 1990 and the Number of enrolments of both sexes in Secondary vocational in 1991?
Provide a succinct answer. 8.74e+04. What is the difference between the Number of enrolments of both sexes of Primary in 1990 and the Number of enrolments of both sexes of Secondary in 1992?
Keep it short and to the point. 1.06e+05. What is the difference between the Number of enrolments of both sexes in Primary in 1990 and the Number of enrolments of both sexes in Secondary general in 1992?
Keep it short and to the point. 2.72e+05. What is the difference between the Number of enrolments of both sexes in Primary in 1990 and the Number of enrolments of both sexes in Secondary vocational in 1992?
Provide a short and direct response. 3.87e+05. What is the difference between the Number of enrolments of both sexes in Secondary in 1990 and the Number of enrolments of both sexes in Secondary general in 1992?
Offer a very short reply. 1.11e+05. What is the difference between the Number of enrolments of both sexes of Secondary in 1990 and the Number of enrolments of both sexes of Secondary vocational in 1992?
Provide a short and direct response. 2.26e+05. What is the difference between the Number of enrolments of both sexes of Secondary general in 1990 and the Number of enrolments of both sexes of Secondary vocational in 1992?
Keep it short and to the point. 8.54e+04. What is the difference between the Number of enrolments of both sexes of Primary in 1990 and the Number of enrolments of both sexes of Secondary in 1993?
Ensure brevity in your answer.  7.34e+04. What is the difference between the Number of enrolments of both sexes of Primary in 1990 and the Number of enrolments of both sexes of Secondary general in 1993?
Your answer should be very brief. 2.09e+05. What is the difference between the Number of enrolments of both sexes of Primary in 1990 and the Number of enrolments of both sexes of Secondary vocational in 1993?
Your answer should be very brief. 3.60e+05. What is the difference between the Number of enrolments of both sexes of Secondary in 1990 and the Number of enrolments of both sexes of Secondary general in 1993?
Offer a very short reply. 4.79e+04. What is the difference between the Number of enrolments of both sexes of Secondary in 1990 and the Number of enrolments of both sexes of Secondary vocational in 1993?
Keep it short and to the point. 1.99e+05. What is the difference between the Number of enrolments of both sexes in Secondary general in 1990 and the Number of enrolments of both sexes in Secondary vocational in 1993?
Make the answer very short. 5.85e+04. What is the difference between the Number of enrolments of both sexes of Primary in 1990 and the Number of enrolments of both sexes of Secondary in 1994?
Give a very brief answer. -1.72e+04. What is the difference between the Number of enrolments of both sexes in Primary in 1990 and the Number of enrolments of both sexes in Secondary general in 1994?
Your response must be concise. 1.85e+05. What is the difference between the Number of enrolments of both sexes in Primary in 1990 and the Number of enrolments of both sexes in Secondary vocational in 1994?
Offer a very short reply. 3.94e+05. What is the difference between the Number of enrolments of both sexes in Secondary in 1990 and the Number of enrolments of both sexes in Secondary general in 1994?
Your response must be concise. 2.36e+04. What is the difference between the Number of enrolments of both sexes in Secondary in 1990 and the Number of enrolments of both sexes in Secondary vocational in 1994?
Provide a succinct answer. 2.32e+05. What is the difference between the Number of enrolments of both sexes of Secondary general in 1990 and the Number of enrolments of both sexes of Secondary vocational in 1994?
Provide a succinct answer. 9.17e+04. What is the difference between the Number of enrolments of both sexes in Primary in 1991 and the Number of enrolments of both sexes in Secondary in 1992?
Offer a terse response. 1.78e+05. What is the difference between the Number of enrolments of both sexes of Primary in 1991 and the Number of enrolments of both sexes of Secondary general in 1992?
Offer a very short reply. 3.44e+05. What is the difference between the Number of enrolments of both sexes of Primary in 1991 and the Number of enrolments of both sexes of Secondary vocational in 1992?
Your response must be concise. 4.59e+05. What is the difference between the Number of enrolments of both sexes of Secondary in 1991 and the Number of enrolments of both sexes of Secondary general in 1992?
Offer a terse response. 1.41e+05. What is the difference between the Number of enrolments of both sexes in Secondary in 1991 and the Number of enrolments of both sexes in Secondary vocational in 1992?
Give a very brief answer. 2.56e+05. What is the difference between the Number of enrolments of both sexes in Secondary general in 1991 and the Number of enrolments of both sexes in Secondary vocational in 1992?
Your answer should be compact. 9.74e+04. What is the difference between the Number of enrolments of both sexes in Primary in 1991 and the Number of enrolments of both sexes in Secondary in 1993?
Provide a short and direct response. 1.45e+05. What is the difference between the Number of enrolments of both sexes of Primary in 1991 and the Number of enrolments of both sexes of Secondary general in 1993?
Make the answer very short. 2.81e+05. What is the difference between the Number of enrolments of both sexes of Primary in 1991 and the Number of enrolments of both sexes of Secondary vocational in 1993?
Offer a terse response. 4.32e+05. What is the difference between the Number of enrolments of both sexes in Secondary in 1991 and the Number of enrolments of both sexes in Secondary general in 1993?
Offer a very short reply. 7.84e+04. What is the difference between the Number of enrolments of both sexes in Secondary in 1991 and the Number of enrolments of both sexes in Secondary vocational in 1993?
Offer a terse response. 2.29e+05. What is the difference between the Number of enrolments of both sexes in Secondary general in 1991 and the Number of enrolments of both sexes in Secondary vocational in 1993?
Offer a very short reply. 7.04e+04. What is the difference between the Number of enrolments of both sexes in Primary in 1991 and the Number of enrolments of both sexes in Secondary in 1994?
Provide a succinct answer. 5.47e+04. What is the difference between the Number of enrolments of both sexes of Primary in 1991 and the Number of enrolments of both sexes of Secondary general in 1994?
Your answer should be compact. 2.57e+05. What is the difference between the Number of enrolments of both sexes in Primary in 1991 and the Number of enrolments of both sexes in Secondary vocational in 1994?
Your response must be concise. 4.66e+05. What is the difference between the Number of enrolments of both sexes in Secondary in 1991 and the Number of enrolments of both sexes in Secondary general in 1994?
Provide a succinct answer. 5.41e+04. What is the difference between the Number of enrolments of both sexes of Secondary in 1991 and the Number of enrolments of both sexes of Secondary vocational in 1994?
Offer a very short reply. 2.63e+05. What is the difference between the Number of enrolments of both sexes of Secondary general in 1991 and the Number of enrolments of both sexes of Secondary vocational in 1994?
Offer a very short reply. 1.04e+05. What is the difference between the Number of enrolments of both sexes in Primary in 1992 and the Number of enrolments of both sexes in Secondary in 1993?
Give a very brief answer. 1.90e+05. What is the difference between the Number of enrolments of both sexes in Primary in 1992 and the Number of enrolments of both sexes in Secondary general in 1993?
Your response must be concise. 3.26e+05. What is the difference between the Number of enrolments of both sexes in Primary in 1992 and the Number of enrolments of both sexes in Secondary vocational in 1993?
Ensure brevity in your answer.  4.77e+05. What is the difference between the Number of enrolments of both sexes of Secondary in 1992 and the Number of enrolments of both sexes of Secondary general in 1993?
Your answer should be very brief. 1.04e+05. What is the difference between the Number of enrolments of both sexes in Secondary in 1992 and the Number of enrolments of both sexes in Secondary vocational in 1993?
Your response must be concise. 2.55e+05. What is the difference between the Number of enrolments of both sexes in Secondary general in 1992 and the Number of enrolments of both sexes in Secondary vocational in 1993?
Your answer should be compact. 8.83e+04. What is the difference between the Number of enrolments of both sexes in Primary in 1992 and the Number of enrolments of both sexes in Secondary in 1994?
Offer a terse response. 9.94e+04. What is the difference between the Number of enrolments of both sexes of Primary in 1992 and the Number of enrolments of both sexes of Secondary general in 1994?
Your answer should be compact. 3.02e+05. What is the difference between the Number of enrolments of both sexes of Primary in 1992 and the Number of enrolments of both sexes of Secondary vocational in 1994?
Keep it short and to the point. 5.10e+05. What is the difference between the Number of enrolments of both sexes of Secondary in 1992 and the Number of enrolments of both sexes of Secondary general in 1994?
Your answer should be very brief. 7.92e+04. What is the difference between the Number of enrolments of both sexes of Secondary in 1992 and the Number of enrolments of both sexes of Secondary vocational in 1994?
Offer a very short reply. 2.88e+05. What is the difference between the Number of enrolments of both sexes in Secondary general in 1992 and the Number of enrolments of both sexes in Secondary vocational in 1994?
Offer a terse response. 1.22e+05. What is the difference between the Number of enrolments of both sexes of Primary in 1993 and the Number of enrolments of both sexes of Secondary in 1994?
Offer a terse response. 1.64e+05. What is the difference between the Number of enrolments of both sexes of Primary in 1993 and the Number of enrolments of both sexes of Secondary general in 1994?
Your response must be concise. 3.67e+05. What is the difference between the Number of enrolments of both sexes of Primary in 1993 and the Number of enrolments of both sexes of Secondary vocational in 1994?
Provide a short and direct response. 5.75e+05. What is the difference between the Number of enrolments of both sexes in Secondary in 1993 and the Number of enrolments of both sexes in Secondary general in 1994?
Offer a very short reply. 1.12e+05. What is the difference between the Number of enrolments of both sexes in Secondary in 1993 and the Number of enrolments of both sexes in Secondary vocational in 1994?
Keep it short and to the point. 3.20e+05. What is the difference between the Number of enrolments of both sexes in Secondary general in 1993 and the Number of enrolments of both sexes in Secondary vocational in 1994?
Your answer should be very brief. 1.84e+05. What is the average Number of enrolments of both sexes of Primary per year?
Your response must be concise. 5.10e+05. What is the average Number of enrolments of both sexes of Secondary per year?
Your answer should be compact. 2.73e+05. What is the average Number of enrolments of both sexes of Secondary general per year?
Your answer should be compact. 1.36e+05. What is the average Number of enrolments of both sexes in Secondary vocational per year?
Offer a very short reply. 2.72e+04. In the year 1987, what is the difference between the Number of enrolments of both sexes in Primary and Number of enrolments of both sexes in Secondary?
Provide a short and direct response. 3.60e+05. In the year 1987, what is the difference between the Number of enrolments of both sexes of Primary and Number of enrolments of both sexes of Secondary general?
Your response must be concise. 3.67e+05. In the year 1987, what is the difference between the Number of enrolments of both sexes in Primary and Number of enrolments of both sexes in Secondary vocational?
Give a very brief answer. 4.55e+05. In the year 1987, what is the difference between the Number of enrolments of both sexes in Secondary and Number of enrolments of both sexes in Secondary general?
Provide a succinct answer. 7050. In the year 1987, what is the difference between the Number of enrolments of both sexes of Secondary and Number of enrolments of both sexes of Secondary vocational?
Offer a terse response. 9.51e+04. In the year 1987, what is the difference between the Number of enrolments of both sexes in Secondary general and Number of enrolments of both sexes in Secondary vocational?
Offer a very short reply. 8.81e+04. In the year 1988, what is the difference between the Number of enrolments of both sexes of Primary and Number of enrolments of both sexes of Secondary?
Keep it short and to the point. 2.57e+05. In the year 1988, what is the difference between the Number of enrolments of both sexes in Primary and Number of enrolments of both sexes in Secondary general?
Your answer should be compact. 3.85e+05. In the year 1988, what is the difference between the Number of enrolments of both sexes of Primary and Number of enrolments of both sexes of Secondary vocational?
Keep it short and to the point. 4.50e+05. In the year 1988, what is the difference between the Number of enrolments of both sexes of Secondary and Number of enrolments of both sexes of Secondary general?
Keep it short and to the point. 1.28e+05. In the year 1988, what is the difference between the Number of enrolments of both sexes in Secondary and Number of enrolments of both sexes in Secondary vocational?
Ensure brevity in your answer.  1.93e+05. In the year 1988, what is the difference between the Number of enrolments of both sexes in Secondary general and Number of enrolments of both sexes in Secondary vocational?
Keep it short and to the point. 6.54e+04. In the year 1989, what is the difference between the Number of enrolments of both sexes in Primary and Number of enrolments of both sexes in Secondary?
Ensure brevity in your answer.  2.53e+05. In the year 1989, what is the difference between the Number of enrolments of both sexes in Primary and Number of enrolments of both sexes in Secondary general?
Ensure brevity in your answer.  4.05e+05. In the year 1989, what is the difference between the Number of enrolments of both sexes of Primary and Number of enrolments of both sexes of Secondary vocational?
Offer a terse response. 4.59e+05. In the year 1989, what is the difference between the Number of enrolments of both sexes of Secondary and Number of enrolments of both sexes of Secondary general?
Offer a terse response. 1.52e+05. In the year 1989, what is the difference between the Number of enrolments of both sexes in Secondary and Number of enrolments of both sexes in Secondary vocational?
Provide a short and direct response. 2.06e+05. In the year 1989, what is the difference between the Number of enrolments of both sexes of Secondary general and Number of enrolments of both sexes of Secondary vocational?
Offer a terse response. 5.39e+04. In the year 1990, what is the difference between the Number of enrolments of both sexes in Primary and Number of enrolments of both sexes in Secondary?
Provide a short and direct response. 1.62e+05. In the year 1990, what is the difference between the Number of enrolments of both sexes in Primary and Number of enrolments of both sexes in Secondary general?
Provide a short and direct response. 3.02e+05. In the year 1990, what is the difference between the Number of enrolments of both sexes in Primary and Number of enrolments of both sexes in Secondary vocational?
Offer a very short reply. 3.94e+05. In the year 1990, what is the difference between the Number of enrolments of both sexes of Secondary and Number of enrolments of both sexes of Secondary general?
Give a very brief answer. 1.40e+05. In the year 1990, what is the difference between the Number of enrolments of both sexes of Secondary and Number of enrolments of both sexes of Secondary vocational?
Offer a very short reply. 2.32e+05. In the year 1990, what is the difference between the Number of enrolments of both sexes in Secondary general and Number of enrolments of both sexes in Secondary vocational?
Make the answer very short. 9.20e+04. In the year 1991, what is the difference between the Number of enrolments of both sexes in Primary and Number of enrolments of both sexes in Secondary?
Provide a short and direct response. 2.03e+05. In the year 1991, what is the difference between the Number of enrolments of both sexes of Primary and Number of enrolments of both sexes of Secondary general?
Ensure brevity in your answer.  3.62e+05. In the year 1991, what is the difference between the Number of enrolments of both sexes in Primary and Number of enrolments of both sexes in Secondary vocational?
Keep it short and to the point. 4.61e+05. In the year 1991, what is the difference between the Number of enrolments of both sexes in Secondary and Number of enrolments of both sexes in Secondary general?
Give a very brief answer. 1.59e+05. In the year 1991, what is the difference between the Number of enrolments of both sexes in Secondary and Number of enrolments of both sexes in Secondary vocational?
Your answer should be very brief. 2.58e+05. In the year 1991, what is the difference between the Number of enrolments of both sexes in Secondary general and Number of enrolments of both sexes in Secondary vocational?
Your response must be concise. 9.94e+04. In the year 1992, what is the difference between the Number of enrolments of both sexes of Primary and Number of enrolments of both sexes of Secondary?
Ensure brevity in your answer.  2.22e+05. In the year 1992, what is the difference between the Number of enrolments of both sexes of Primary and Number of enrolments of both sexes of Secondary general?
Your answer should be very brief. 3.89e+05. In the year 1992, what is the difference between the Number of enrolments of both sexes in Primary and Number of enrolments of both sexes in Secondary vocational?
Provide a succinct answer. 5.04e+05. In the year 1992, what is the difference between the Number of enrolments of both sexes of Secondary and Number of enrolments of both sexes of Secondary general?
Offer a terse response. 1.66e+05. In the year 1992, what is the difference between the Number of enrolments of both sexes in Secondary and Number of enrolments of both sexes in Secondary vocational?
Your response must be concise. 2.82e+05. In the year 1992, what is the difference between the Number of enrolments of both sexes in Secondary general and Number of enrolments of both sexes in Secondary vocational?
Your answer should be very brief. 1.15e+05. In the year 1993, what is the difference between the Number of enrolments of both sexes of Primary and Number of enrolments of both sexes of Secondary?
Make the answer very short. 2.55e+05. In the year 1993, what is the difference between the Number of enrolments of both sexes of Primary and Number of enrolments of both sexes of Secondary general?
Your answer should be compact. 3.91e+05. In the year 1993, what is the difference between the Number of enrolments of both sexes in Primary and Number of enrolments of both sexes in Secondary vocational?
Provide a succinct answer. 5.42e+05. In the year 1993, what is the difference between the Number of enrolments of both sexes of Secondary and Number of enrolments of both sexes of Secondary general?
Keep it short and to the point. 1.36e+05. In the year 1993, what is the difference between the Number of enrolments of both sexes of Secondary and Number of enrolments of both sexes of Secondary vocational?
Keep it short and to the point. 2.87e+05. In the year 1993, what is the difference between the Number of enrolments of both sexes in Secondary general and Number of enrolments of both sexes in Secondary vocational?
Make the answer very short. 1.51e+05. In the year 1994, what is the difference between the Number of enrolments of both sexes of Primary and Number of enrolments of both sexes of Secondary?
Offer a very short reply. 1.89e+05. In the year 1994, what is the difference between the Number of enrolments of both sexes of Primary and Number of enrolments of both sexes of Secondary general?
Offer a terse response. 3.92e+05. In the year 1994, what is the difference between the Number of enrolments of both sexes of Primary and Number of enrolments of both sexes of Secondary vocational?
Give a very brief answer. 6.00e+05. In the year 1994, what is the difference between the Number of enrolments of both sexes of Secondary and Number of enrolments of both sexes of Secondary general?
Your response must be concise. 2.02e+05. In the year 1994, what is the difference between the Number of enrolments of both sexes in Secondary and Number of enrolments of both sexes in Secondary vocational?
Give a very brief answer. 4.11e+05. In the year 1994, what is the difference between the Number of enrolments of both sexes in Secondary general and Number of enrolments of both sexes in Secondary vocational?
Provide a succinct answer. 2.09e+05. What is the ratio of the Number of enrolments of both sexes of Primary in 1987 to that in 1988?
Ensure brevity in your answer.  0.98. What is the ratio of the Number of enrolments of both sexes in Secondary in 1987 to that in 1988?
Make the answer very short. 0.48. What is the ratio of the Number of enrolments of both sexes of Secondary general in 1987 to that in 1988?
Offer a very short reply. 1.11. What is the ratio of the Number of enrolments of both sexes of Secondary vocational in 1987 to that in 1988?
Offer a terse response. 0.35. What is the ratio of the Number of enrolments of both sexes of Primary in 1987 to that in 1989?
Your answer should be very brief. 0.96. What is the ratio of the Number of enrolments of both sexes of Secondary in 1987 to that in 1989?
Keep it short and to the point. 0.45. What is the ratio of the Number of enrolments of both sexes in Secondary general in 1987 to that in 1989?
Keep it short and to the point. 1.23. What is the ratio of the Number of enrolments of both sexes in Secondary vocational in 1987 to that in 1989?
Your response must be concise. 0.3. What is the ratio of the Number of enrolments of both sexes in Primary in 1987 to that in 1990?
Provide a short and direct response. 1.1. What is the ratio of the Number of enrolments of both sexes of Secondary in 1987 to that in 1990?
Give a very brief answer. 0.4. What is the ratio of the Number of enrolments of both sexes of Secondary general in 1987 to that in 1990?
Ensure brevity in your answer.  0.82. What is the ratio of the Number of enrolments of both sexes of Secondary vocational in 1987 to that in 1990?
Your answer should be compact. 0.29. What is the ratio of the Number of enrolments of both sexes of Primary in 1987 to that in 1991?
Ensure brevity in your answer.  0.94. What is the ratio of the Number of enrolments of both sexes of Secondary in 1987 to that in 1991?
Make the answer very short. 0.36. What is the ratio of the Number of enrolments of both sexes in Secondary general in 1987 to that in 1991?
Provide a succinct answer. 0.74. What is the ratio of the Number of enrolments of both sexes in Secondary vocational in 1987 to that in 1991?
Give a very brief answer. 0.24. What is the ratio of the Number of enrolments of both sexes in Primary in 1987 to that in 1992?
Offer a very short reply. 0.86. What is the ratio of the Number of enrolments of both sexes in Secondary in 1987 to that in 1992?
Give a very brief answer. 0.33. What is the ratio of the Number of enrolments of both sexes in Secondary general in 1987 to that in 1992?
Offer a very short reply. 0.65. What is the ratio of the Number of enrolments of both sexes of Secondary vocational in 1987 to that in 1992?
Ensure brevity in your answer.  0.23. What is the ratio of the Number of enrolments of both sexes of Primary in 1987 to that in 1993?
Give a very brief answer. 0.77. What is the ratio of the Number of enrolments of both sexes in Secondary in 1987 to that in 1993?
Ensure brevity in your answer.  0.3. What is the ratio of the Number of enrolments of both sexes of Secondary general in 1987 to that in 1993?
Give a very brief answer. 0.46. What is the ratio of the Number of enrolments of both sexes in Secondary vocational in 1987 to that in 1993?
Provide a short and direct response. 0.12. What is the ratio of the Number of enrolments of both sexes in Primary in 1987 to that in 1994?
Provide a short and direct response. 0.74. What is the ratio of the Number of enrolments of both sexes of Secondary in 1987 to that in 1994?
Ensure brevity in your answer.  0.23. What is the ratio of the Number of enrolments of both sexes in Secondary general in 1987 to that in 1994?
Your answer should be compact. 0.41. What is the ratio of the Number of enrolments of both sexes in Secondary vocational in 1987 to that in 1994?
Offer a terse response. 0.29. What is the ratio of the Number of enrolments of both sexes in Primary in 1988 to that in 1989?
Give a very brief answer. 0.97. What is the ratio of the Number of enrolments of both sexes of Secondary in 1988 to that in 1989?
Your answer should be compact. 0.93. What is the ratio of the Number of enrolments of both sexes in Secondary general in 1988 to that in 1989?
Your answer should be compact. 1.11. What is the ratio of the Number of enrolments of both sexes in Secondary vocational in 1988 to that in 1989?
Offer a very short reply. 0.86. What is the ratio of the Number of enrolments of both sexes in Primary in 1988 to that in 1990?
Ensure brevity in your answer.  1.12. What is the ratio of the Number of enrolments of both sexes of Secondary in 1988 to that in 1990?
Provide a short and direct response. 0.83. What is the ratio of the Number of enrolments of both sexes of Secondary general in 1988 to that in 1990?
Give a very brief answer. 0.74. What is the ratio of the Number of enrolments of both sexes of Secondary vocational in 1988 to that in 1990?
Offer a very short reply. 0.84. What is the ratio of the Number of enrolments of both sexes in Primary in 1988 to that in 1991?
Your response must be concise. 0.96. What is the ratio of the Number of enrolments of both sexes of Secondary in 1988 to that in 1991?
Ensure brevity in your answer.  0.74. What is the ratio of the Number of enrolments of both sexes of Secondary general in 1988 to that in 1991?
Your response must be concise. 0.67. What is the ratio of the Number of enrolments of both sexes in Secondary vocational in 1988 to that in 1991?
Your response must be concise. 0.7. What is the ratio of the Number of enrolments of both sexes of Primary in 1988 to that in 1992?
Your answer should be compact. 0.88. What is the ratio of the Number of enrolments of both sexes of Secondary in 1988 to that in 1992?
Your response must be concise. 0.68. What is the ratio of the Number of enrolments of both sexes of Secondary general in 1988 to that in 1992?
Your answer should be compact. 0.59. What is the ratio of the Number of enrolments of both sexes in Secondary vocational in 1988 to that in 1992?
Make the answer very short. 0.66. What is the ratio of the Number of enrolments of both sexes of Primary in 1988 to that in 1993?
Give a very brief answer. 0.78. What is the ratio of the Number of enrolments of both sexes of Secondary in 1988 to that in 1993?
Offer a very short reply. 0.62. What is the ratio of the Number of enrolments of both sexes in Secondary general in 1988 to that in 1993?
Provide a short and direct response. 0.41. What is the ratio of the Number of enrolments of both sexes of Secondary vocational in 1988 to that in 1993?
Your response must be concise. 0.35. What is the ratio of the Number of enrolments of both sexes of Primary in 1988 to that in 1994?
Make the answer very short. 0.75. What is the ratio of the Number of enrolments of both sexes in Secondary in 1988 to that in 1994?
Keep it short and to the point. 0.49. What is the ratio of the Number of enrolments of both sexes in Secondary general in 1988 to that in 1994?
Your answer should be very brief. 0.37. What is the ratio of the Number of enrolments of both sexes of Secondary vocational in 1988 to that in 1994?
Offer a terse response. 0.83. What is the ratio of the Number of enrolments of both sexes of Primary in 1989 to that in 1990?
Provide a succinct answer. 1.15. What is the ratio of the Number of enrolments of both sexes in Secondary in 1989 to that in 1990?
Your response must be concise. 0.89. What is the ratio of the Number of enrolments of both sexes in Secondary general in 1989 to that in 1990?
Your response must be concise. 0.67. What is the ratio of the Number of enrolments of both sexes of Secondary vocational in 1989 to that in 1990?
Your answer should be compact. 0.97. What is the ratio of the Number of enrolments of both sexes in Primary in 1989 to that in 1991?
Provide a short and direct response. 0.98. What is the ratio of the Number of enrolments of both sexes of Secondary in 1989 to that in 1991?
Offer a very short reply. 0.8. What is the ratio of the Number of enrolments of both sexes in Secondary general in 1989 to that in 1991?
Keep it short and to the point. 0.6. What is the ratio of the Number of enrolments of both sexes in Secondary vocational in 1989 to that in 1991?
Ensure brevity in your answer.  0.82. What is the ratio of the Number of enrolments of both sexes of Primary in 1989 to that in 1992?
Keep it short and to the point. 0.9. What is the ratio of the Number of enrolments of both sexes of Secondary in 1989 to that in 1992?
Offer a very short reply. 0.73. What is the ratio of the Number of enrolments of both sexes in Secondary general in 1989 to that in 1992?
Make the answer very short. 0.53. What is the ratio of the Number of enrolments of both sexes in Secondary vocational in 1989 to that in 1992?
Your response must be concise. 0.76. What is the ratio of the Number of enrolments of both sexes in Primary in 1989 to that in 1993?
Ensure brevity in your answer.  0.8. What is the ratio of the Number of enrolments of both sexes in Secondary in 1989 to that in 1993?
Provide a succinct answer. 0.66. What is the ratio of the Number of enrolments of both sexes in Secondary general in 1989 to that in 1993?
Ensure brevity in your answer.  0.37. What is the ratio of the Number of enrolments of both sexes of Secondary vocational in 1989 to that in 1993?
Make the answer very short. 0.41. What is the ratio of the Number of enrolments of both sexes in Primary in 1989 to that in 1994?
Make the answer very short. 0.77. What is the ratio of the Number of enrolments of both sexes in Secondary in 1989 to that in 1994?
Your answer should be compact. 0.53. What is the ratio of the Number of enrolments of both sexes of Secondary general in 1989 to that in 1994?
Your answer should be compact. 0.33. What is the ratio of the Number of enrolments of both sexes in Primary in 1990 to that in 1991?
Offer a terse response. 0.85. What is the ratio of the Number of enrolments of both sexes in Secondary in 1990 to that in 1991?
Provide a succinct answer. 0.89. What is the ratio of the Number of enrolments of both sexes in Secondary general in 1990 to that in 1991?
Provide a succinct answer. 0.91. What is the ratio of the Number of enrolments of both sexes in Secondary vocational in 1990 to that in 1991?
Your response must be concise. 0.84. What is the ratio of the Number of enrolments of both sexes of Primary in 1990 to that in 1992?
Offer a terse response. 0.78. What is the ratio of the Number of enrolments of both sexes in Secondary in 1990 to that in 1992?
Your answer should be compact. 0.82. What is the ratio of the Number of enrolments of both sexes of Secondary general in 1990 to that in 1992?
Ensure brevity in your answer.  0.8. What is the ratio of the Number of enrolments of both sexes of Secondary vocational in 1990 to that in 1992?
Give a very brief answer. 0.79. What is the ratio of the Number of enrolments of both sexes of Primary in 1990 to that in 1993?
Offer a very short reply. 0.7. What is the ratio of the Number of enrolments of both sexes in Secondary in 1990 to that in 1993?
Your answer should be compact. 0.74. What is the ratio of the Number of enrolments of both sexes of Secondary general in 1990 to that in 1993?
Make the answer very short. 0.56. What is the ratio of the Number of enrolments of both sexes of Secondary vocational in 1990 to that in 1993?
Provide a succinct answer. 0.42. What is the ratio of the Number of enrolments of both sexes in Primary in 1990 to that in 1994?
Your answer should be very brief. 0.67. What is the ratio of the Number of enrolments of both sexes in Secondary in 1990 to that in 1994?
Give a very brief answer. 0.59. What is the ratio of the Number of enrolments of both sexes of Secondary general in 1990 to that in 1994?
Give a very brief answer. 0.5. What is the ratio of the Number of enrolments of both sexes in Primary in 1991 to that in 1992?
Offer a terse response. 0.92. What is the ratio of the Number of enrolments of both sexes of Secondary in 1991 to that in 1992?
Provide a succinct answer. 0.92. What is the ratio of the Number of enrolments of both sexes in Secondary general in 1991 to that in 1992?
Provide a short and direct response. 0.88. What is the ratio of the Number of enrolments of both sexes in Secondary vocational in 1991 to that in 1992?
Offer a very short reply. 0.93. What is the ratio of the Number of enrolments of both sexes of Primary in 1991 to that in 1993?
Your answer should be very brief. 0.82. What is the ratio of the Number of enrolments of both sexes in Secondary in 1991 to that in 1993?
Provide a short and direct response. 0.83. What is the ratio of the Number of enrolments of both sexes of Secondary general in 1991 to that in 1993?
Offer a very short reply. 0.61. What is the ratio of the Number of enrolments of both sexes of Secondary vocational in 1991 to that in 1993?
Provide a short and direct response. 0.5. What is the ratio of the Number of enrolments of both sexes in Primary in 1991 to that in 1994?
Your response must be concise. 0.78. What is the ratio of the Number of enrolments of both sexes of Secondary in 1991 to that in 1994?
Make the answer very short. 0.66. What is the ratio of the Number of enrolments of both sexes of Secondary general in 1991 to that in 1994?
Your answer should be compact. 0.55. What is the ratio of the Number of enrolments of both sexes of Secondary vocational in 1991 to that in 1994?
Ensure brevity in your answer.  1.17. What is the ratio of the Number of enrolments of both sexes of Primary in 1992 to that in 1993?
Keep it short and to the point. 0.89. What is the ratio of the Number of enrolments of both sexes in Secondary in 1992 to that in 1993?
Provide a succinct answer. 0.91. What is the ratio of the Number of enrolments of both sexes of Secondary general in 1992 to that in 1993?
Offer a terse response. 0.7. What is the ratio of the Number of enrolments of both sexes of Secondary vocational in 1992 to that in 1993?
Provide a short and direct response. 0.53. What is the ratio of the Number of enrolments of both sexes in Primary in 1992 to that in 1994?
Give a very brief answer. 0.86. What is the ratio of the Number of enrolments of both sexes of Secondary in 1992 to that in 1994?
Your response must be concise. 0.72. What is the ratio of the Number of enrolments of both sexes in Secondary general in 1992 to that in 1994?
Your response must be concise. 0.63. What is the ratio of the Number of enrolments of both sexes in Secondary vocational in 1992 to that in 1994?
Offer a terse response. 1.25. What is the ratio of the Number of enrolments of both sexes of Primary in 1993 to that in 1994?
Ensure brevity in your answer.  0.96. What is the ratio of the Number of enrolments of both sexes in Secondary in 1993 to that in 1994?
Provide a succinct answer. 0.79. What is the ratio of the Number of enrolments of both sexes of Secondary general in 1993 to that in 1994?
Offer a very short reply. 0.9. What is the ratio of the Number of enrolments of both sexes of Secondary vocational in 1993 to that in 1994?
Ensure brevity in your answer.  2.35. What is the difference between the highest and the second highest Number of enrolments of both sexes in Primary?
Make the answer very short. 2.49e+04. What is the difference between the highest and the second highest Number of enrolments of both sexes of Secondary?
Your answer should be compact. 9.06e+04. What is the difference between the highest and the second highest Number of enrolments of both sexes in Secondary general?
Your answer should be very brief. 2.43e+04. What is the difference between the highest and the second highest Number of enrolments of both sexes of Secondary vocational?
Your answer should be very brief. 2.69e+04. What is the difference between the highest and the lowest Number of enrolments of both sexes of Primary?
Your response must be concise. 2.07e+05. What is the difference between the highest and the lowest Number of enrolments of both sexes in Secondary?
Provide a succinct answer. 3.33e+05. What is the difference between the highest and the lowest Number of enrolments of both sexes in Secondary general?
Offer a terse response. 1.56e+05. What is the difference between the highest and the lowest Number of enrolments of both sexes of Secondary vocational?
Your response must be concise. 5.08e+04. 